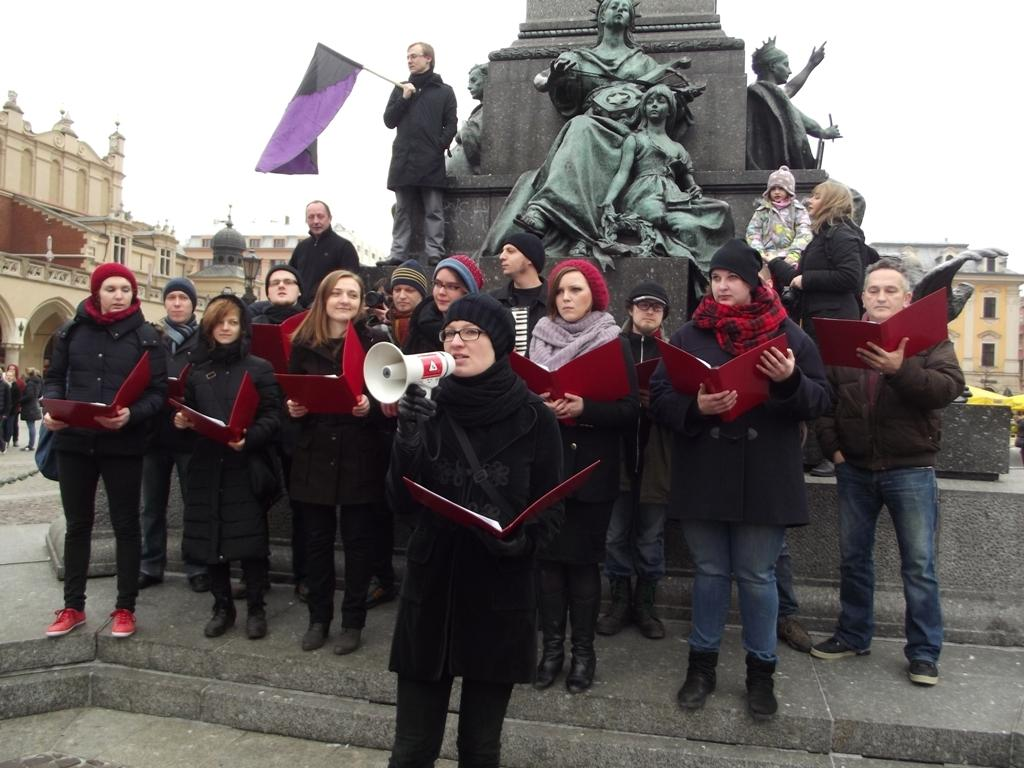Who is the main subject in the image? There is a woman standing in the center of the image. What is the woman standing on? The woman is standing on the floor. What can be seen in the background of the image? There are statues, a person holding a flag, buildings, and other persons visible in the background. What is visible in the sky in the image? The sky is visible in the background of the image. How many owls are sitting on the woman's shoulders in the image? There are no owls present in the image. What type of play is the woman participating in with the other women in the image? There are no other women present in the image, and no play is taking place. 